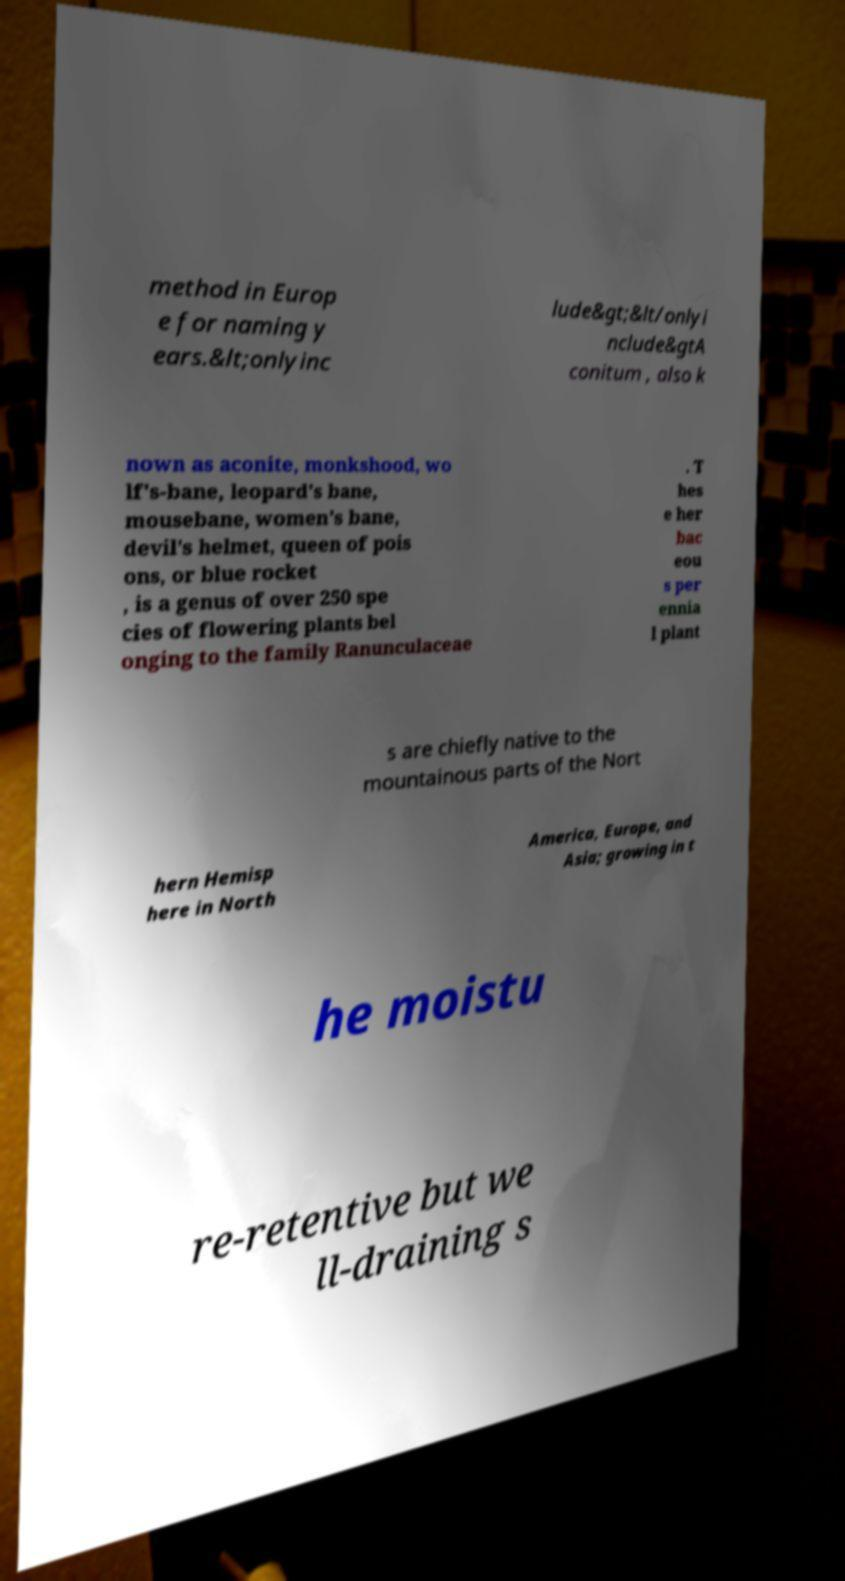Can you accurately transcribe the text from the provided image for me? method in Europ e for naming y ears.&lt;onlyinc lude&gt;&lt/onlyi nclude&gtA conitum , also k nown as aconite, monkshood, wo lf's-bane, leopard's bane, mousebane, women's bane, devil's helmet, queen of pois ons, or blue rocket , is a genus of over 250 spe cies of flowering plants bel onging to the family Ranunculaceae . T hes e her bac eou s per ennia l plant s are chiefly native to the mountainous parts of the Nort hern Hemisp here in North America, Europe, and Asia; growing in t he moistu re-retentive but we ll-draining s 